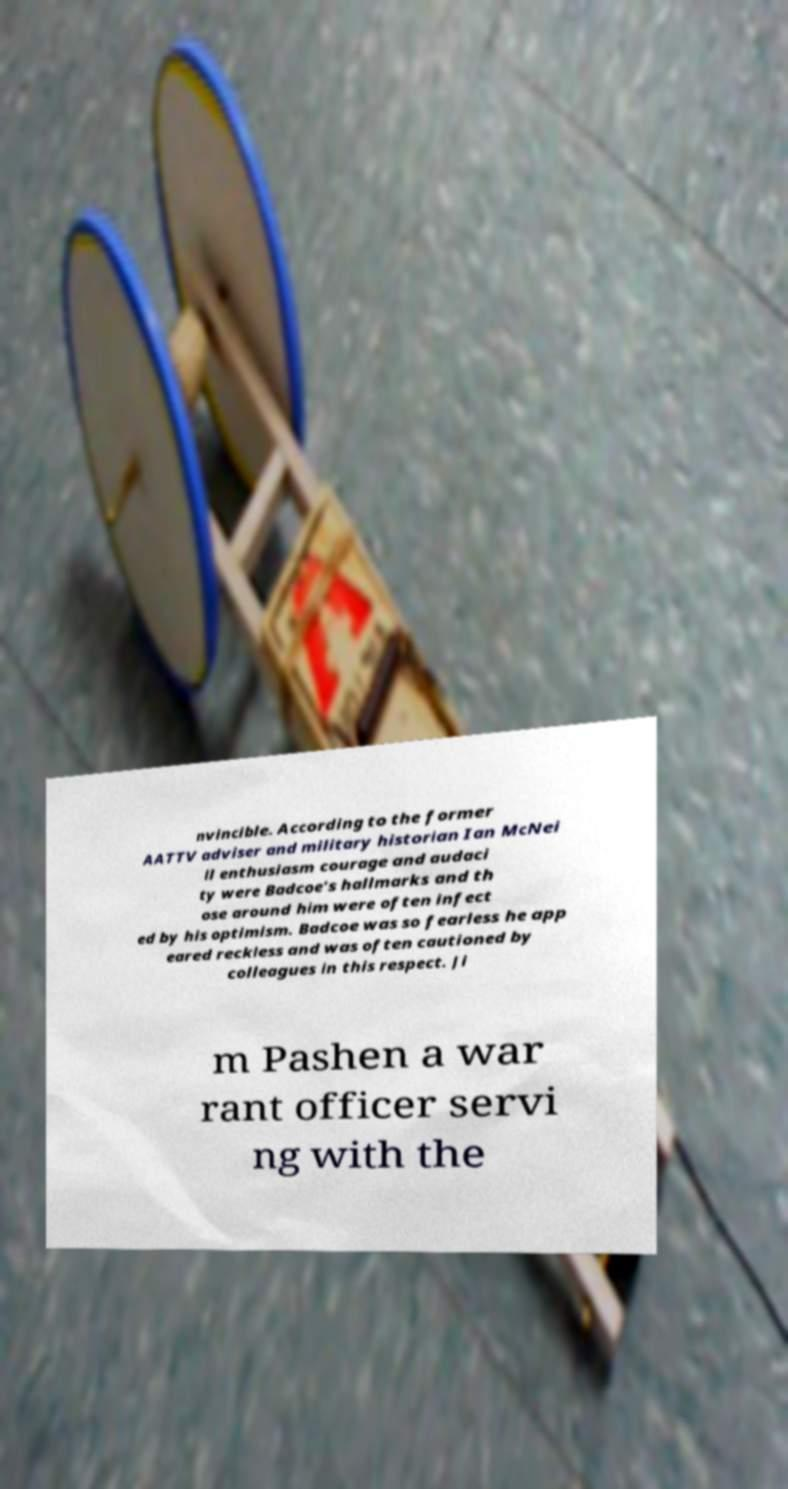Please read and relay the text visible in this image. What does it say? nvincible. According to the former AATTV adviser and military historian Ian McNei ll enthusiasm courage and audaci ty were Badcoe's hallmarks and th ose around him were often infect ed by his optimism. Badcoe was so fearless he app eared reckless and was often cautioned by colleagues in this respect. Ji m Pashen a war rant officer servi ng with the 